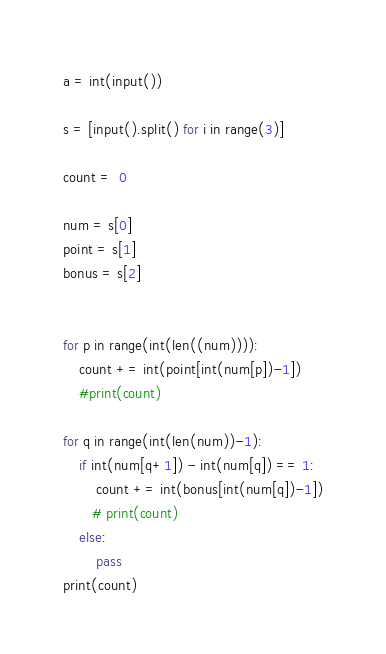<code> <loc_0><loc_0><loc_500><loc_500><_Python_>a = int(input())

s = [input().split() for i in range(3)]

count =  0

num = s[0]
point = s[1]
bonus = s[2]


for p in range(int(len((num)))):
    count += int(point[int(num[p])-1])
    #print(count)

for q in range(int(len(num))-1):
    if int(num[q+1]) - int(num[q]) == 1:
        count += int(bonus[int(num[q])-1])
       # print(count)
    else:
        pass
print(count)</code> 